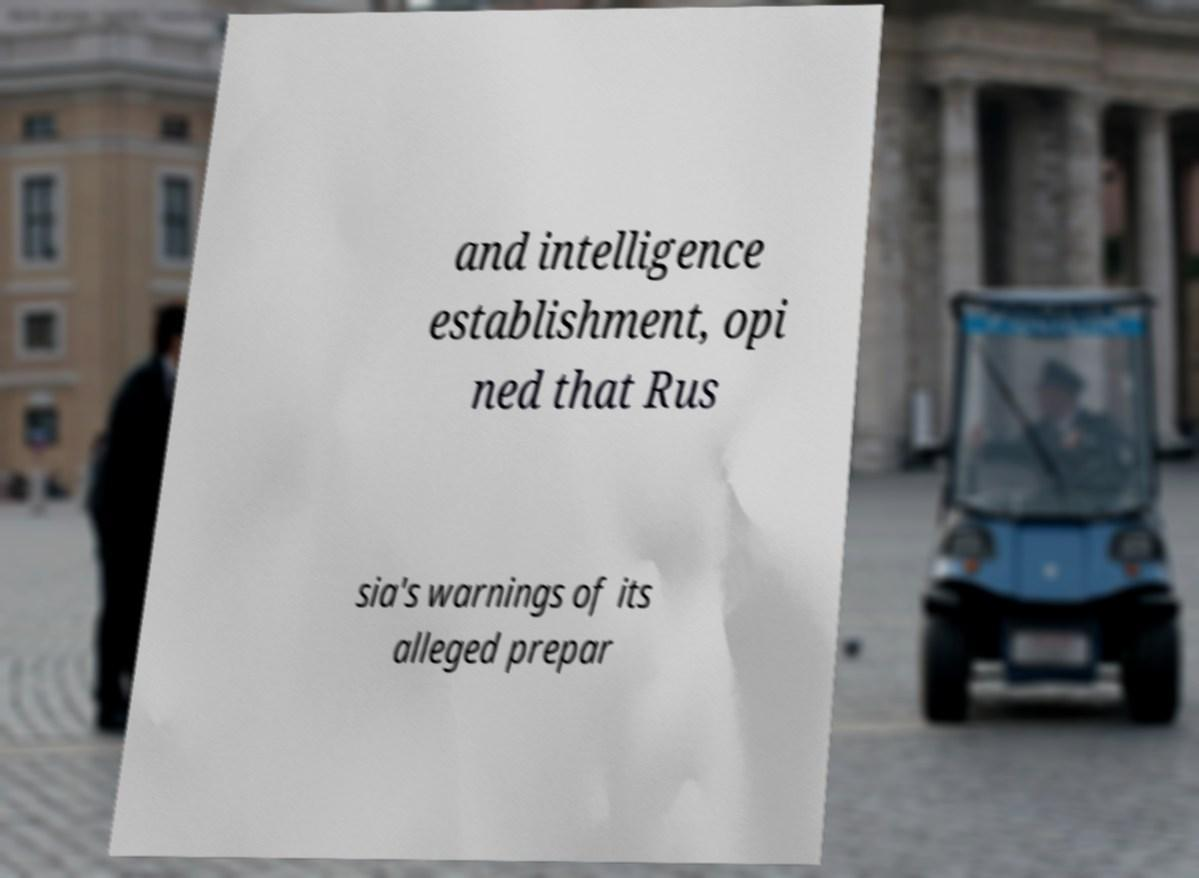Can you read and provide the text displayed in the image?This photo seems to have some interesting text. Can you extract and type it out for me? and intelligence establishment, opi ned that Rus sia's warnings of its alleged prepar 